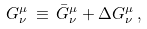Convert formula to latex. <formula><loc_0><loc_0><loc_500><loc_500>G ^ { \mu } _ { \nu } \, \equiv \, { \bar { G } } ^ { \mu } _ { \nu } + \Delta G ^ { \mu } _ { \nu } \, ,</formula> 